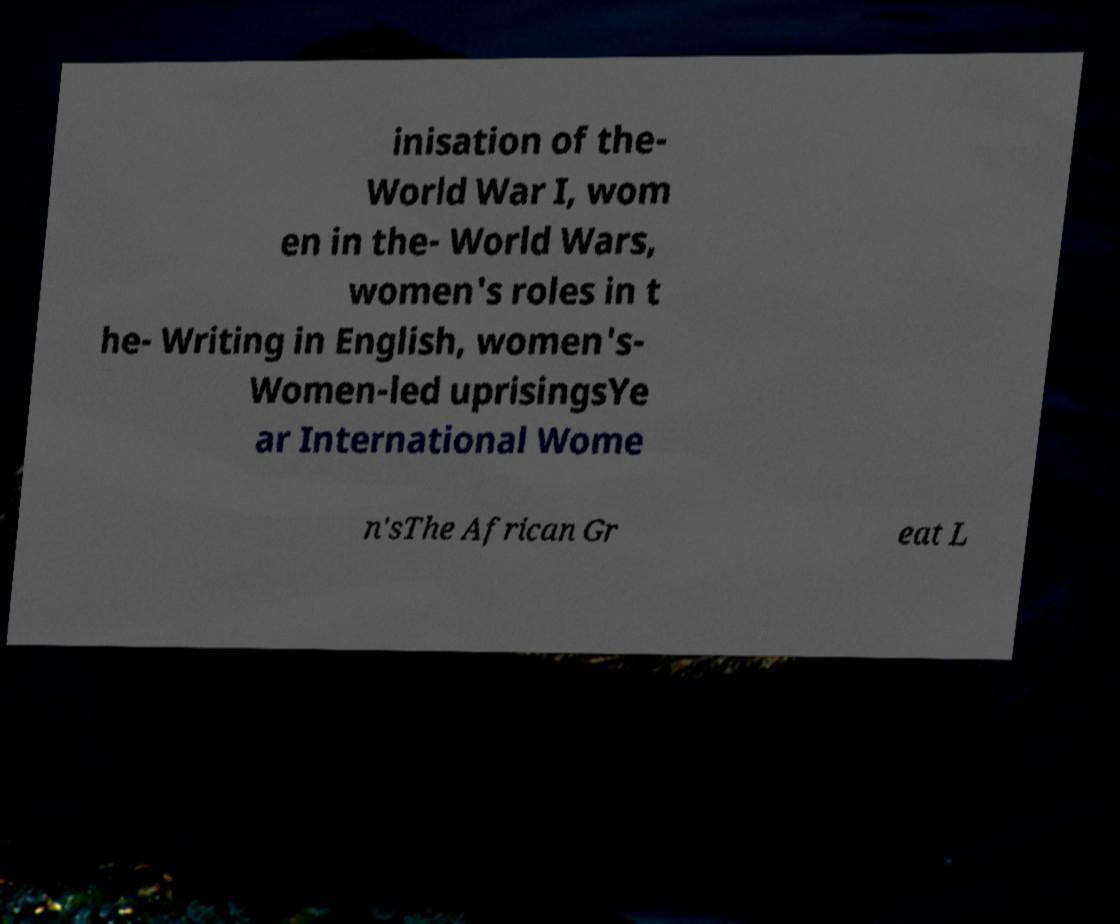Can you read and provide the text displayed in the image?This photo seems to have some interesting text. Can you extract and type it out for me? inisation of the- World War I, wom en in the- World Wars, women's roles in t he- Writing in English, women's- Women-led uprisingsYe ar International Wome n'sThe African Gr eat L 